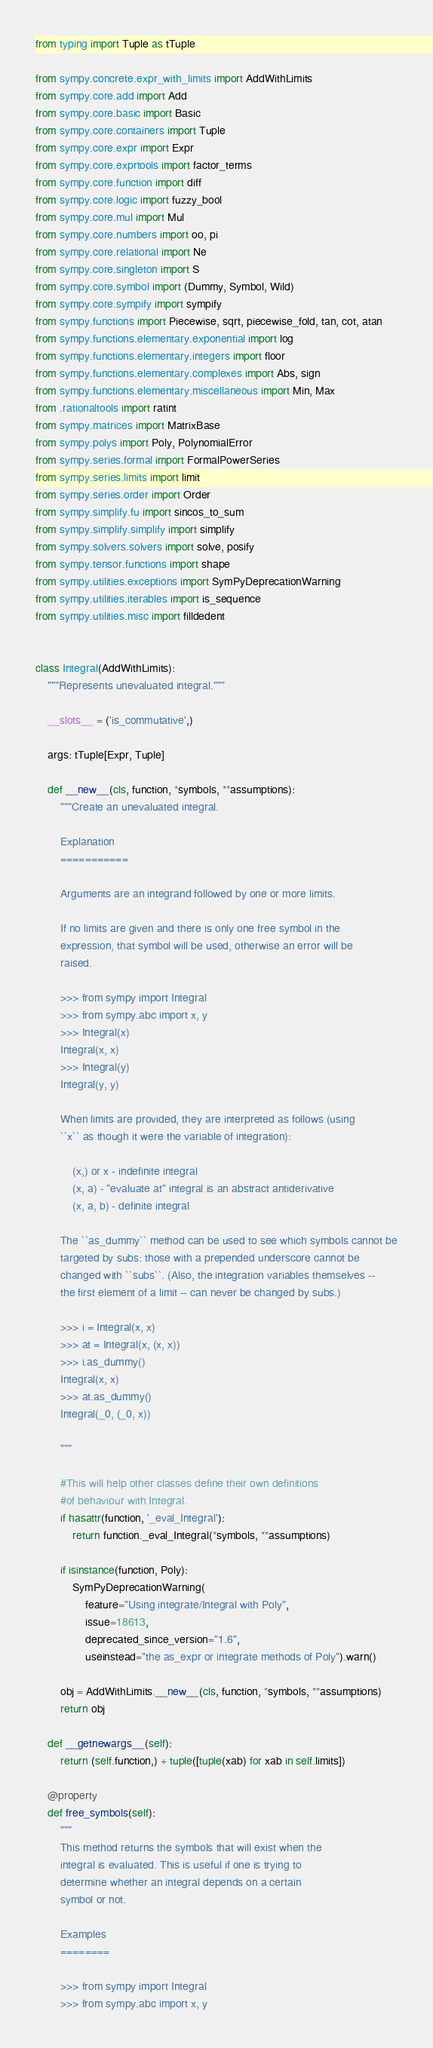<code> <loc_0><loc_0><loc_500><loc_500><_Python_>from typing import Tuple as tTuple

from sympy.concrete.expr_with_limits import AddWithLimits
from sympy.core.add import Add
from sympy.core.basic import Basic
from sympy.core.containers import Tuple
from sympy.core.expr import Expr
from sympy.core.exprtools import factor_terms
from sympy.core.function import diff
from sympy.core.logic import fuzzy_bool
from sympy.core.mul import Mul
from sympy.core.numbers import oo, pi
from sympy.core.relational import Ne
from sympy.core.singleton import S
from sympy.core.symbol import (Dummy, Symbol, Wild)
from sympy.core.sympify import sympify
from sympy.functions import Piecewise, sqrt, piecewise_fold, tan, cot, atan
from sympy.functions.elementary.exponential import log
from sympy.functions.elementary.integers import floor
from sympy.functions.elementary.complexes import Abs, sign
from sympy.functions.elementary.miscellaneous import Min, Max
from .rationaltools import ratint
from sympy.matrices import MatrixBase
from sympy.polys import Poly, PolynomialError
from sympy.series.formal import FormalPowerSeries
from sympy.series.limits import limit
from sympy.series.order import Order
from sympy.simplify.fu import sincos_to_sum
from sympy.simplify.simplify import simplify
from sympy.solvers.solvers import solve, posify
from sympy.tensor.functions import shape
from sympy.utilities.exceptions import SymPyDeprecationWarning
from sympy.utilities.iterables import is_sequence
from sympy.utilities.misc import filldedent


class Integral(AddWithLimits):
    """Represents unevaluated integral."""

    __slots__ = ('is_commutative',)

    args: tTuple[Expr, Tuple]

    def __new__(cls, function, *symbols, **assumptions):
        """Create an unevaluated integral.

        Explanation
        ===========

        Arguments are an integrand followed by one or more limits.

        If no limits are given and there is only one free symbol in the
        expression, that symbol will be used, otherwise an error will be
        raised.

        >>> from sympy import Integral
        >>> from sympy.abc import x, y
        >>> Integral(x)
        Integral(x, x)
        >>> Integral(y)
        Integral(y, y)

        When limits are provided, they are interpreted as follows (using
        ``x`` as though it were the variable of integration):

            (x,) or x - indefinite integral
            (x, a) - "evaluate at" integral is an abstract antiderivative
            (x, a, b) - definite integral

        The ``as_dummy`` method can be used to see which symbols cannot be
        targeted by subs: those with a prepended underscore cannot be
        changed with ``subs``. (Also, the integration variables themselves --
        the first element of a limit -- can never be changed by subs.)

        >>> i = Integral(x, x)
        >>> at = Integral(x, (x, x))
        >>> i.as_dummy()
        Integral(x, x)
        >>> at.as_dummy()
        Integral(_0, (_0, x))

        """

        #This will help other classes define their own definitions
        #of behaviour with Integral.
        if hasattr(function, '_eval_Integral'):
            return function._eval_Integral(*symbols, **assumptions)

        if isinstance(function, Poly):
            SymPyDeprecationWarning(
                feature="Using integrate/Integral with Poly",
                issue=18613,
                deprecated_since_version="1.6",
                useinstead="the as_expr or integrate methods of Poly").warn()

        obj = AddWithLimits.__new__(cls, function, *symbols, **assumptions)
        return obj

    def __getnewargs__(self):
        return (self.function,) + tuple([tuple(xab) for xab in self.limits])

    @property
    def free_symbols(self):
        """
        This method returns the symbols that will exist when the
        integral is evaluated. This is useful if one is trying to
        determine whether an integral depends on a certain
        symbol or not.

        Examples
        ========

        >>> from sympy import Integral
        >>> from sympy.abc import x, y</code> 